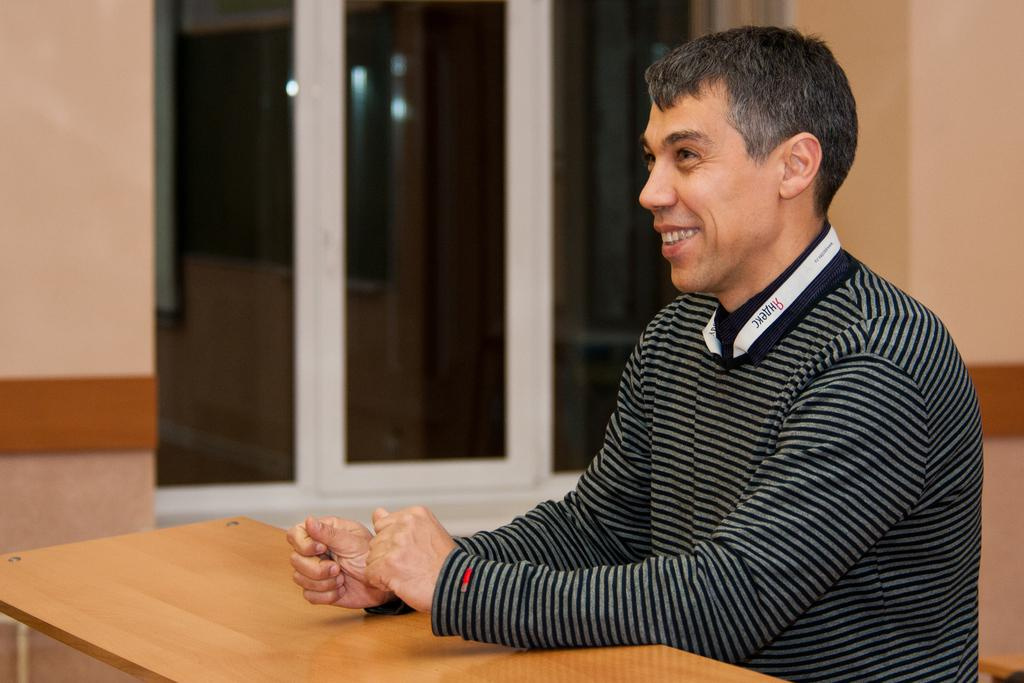What is the man in the image doing? The man is seated in the image. What is present in the image besides the man? There is a table and a window in the image. How is the man's facial expression described? The man has a smile on his face. What color is the rose on the table in the image? There is no rose present in the image. What does the man's voice sound like in the image? The image is still, so there is no sound or voice present. 